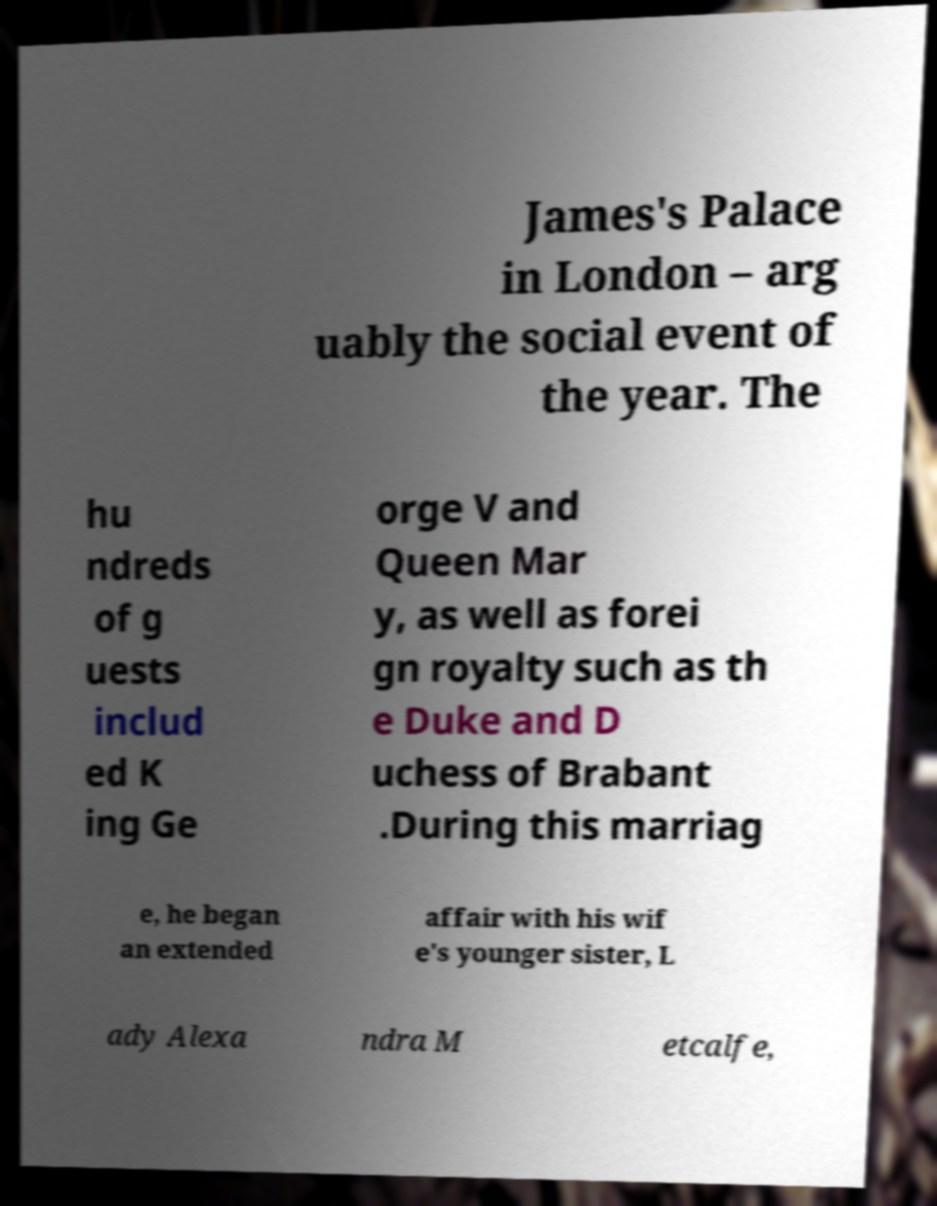Could you extract and type out the text from this image? James's Palace in London – arg uably the social event of the year. The hu ndreds of g uests includ ed K ing Ge orge V and Queen Mar y, as well as forei gn royalty such as th e Duke and D uchess of Brabant .During this marriag e, he began an extended affair with his wif e's younger sister, L ady Alexa ndra M etcalfe, 